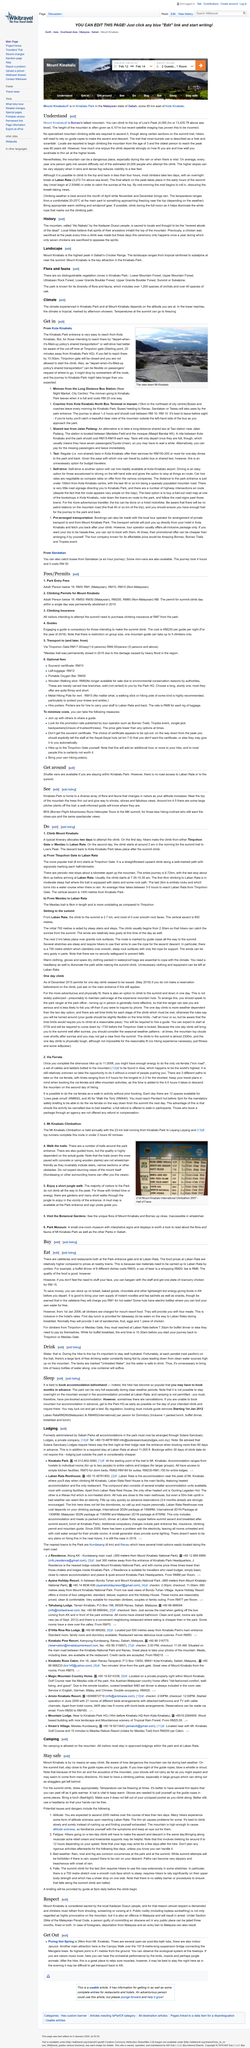Mention a couple of crucial points in this snapshot. A typical itinerary for climbing Mount Kinabalu allocates two days for the climb, allowing sufficient time to ascend to the summit and safely return. A can of beer at Laban Rata costs RM20. The majority of visitors to the Park do not climb all the way to the peak. The Timpohon gate at Kinbalu Park closes at 10:30am. It is essential to wear a hat in order to stay warm. 